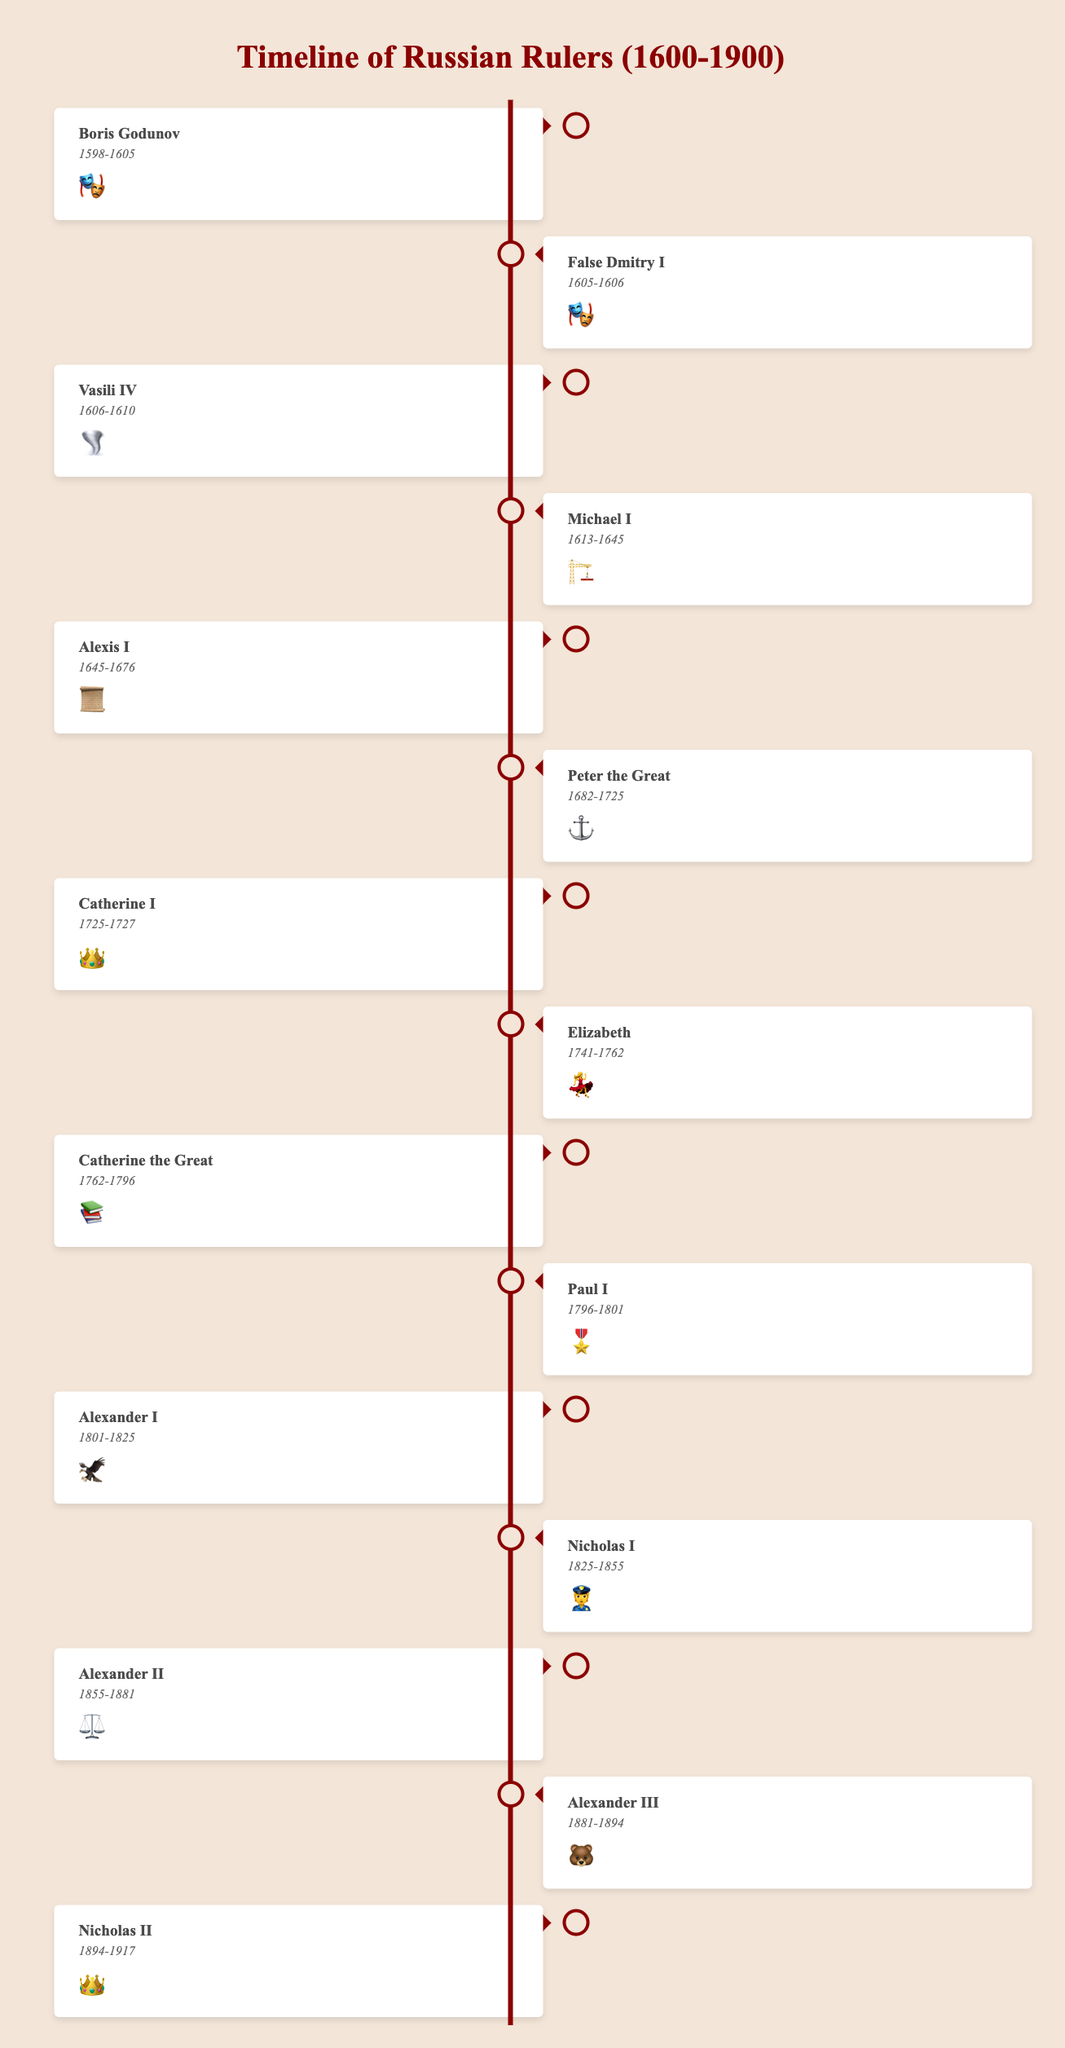How long did Boris Godunov rule? The timeline indicates that Boris Godunov ruled from 1598 to 1605. The length of his reign is the difference between these two years. 1605 - 1598 = 7 years.
Answer: 7 years Which ruler has the emoji 🎭 and what does it signify about them? Both Boris Godunov and False Dmitry I have the emoji 🎭. This likely signifies a dramatic or theatrical aspect of their reigns.
Answer: Boris Godunov and False Dmitry I Who was the ruler during the reign period 1762-1796 and what was their notable characteristic? From the timeline, it shows that Catherine the Great ruled from 1762 to 1796. Her notable characteristic is represented by the emoji 📚, indicating education or enlightenment.
Answer: Catherine the Great, 📚 Which ruler reigned directly after Peter the Great and what emoji represents them? According to the timeline, Catherine I ruled directly after Peter the Great. She is represented by the emoji 👑.
Answer: Catherine I, 👑 Compare the reign periods of Alexis I and Michael I. Who ruled longer and by how many years? Michael I reigned from 1613-1645 (32 years) and Alexis I from 1645-1676 (31 years). Michael I ruled longer by 1 year.
Answer: Michael I, 1 year longer Identify the ruler whose reign is represented by the emoji ⚓ and explain what it might symbolize. Peter the Great's reign, depicted by the emoji ⚓, possibly symbolizes his naval reforms and the expansion of the Russian navy.
Answer: Peter the Great, ⚓ What is the combined length of reigns for the rulers depicted with an emoji of a book? The only ruler with the book emoji (📚) is Catherine the Great, who ruled from 1762 to 1796, which totals 34 years.
Answer: 34 years How many rulers reigned from 1800-1900, and what are their notable characteristics? From the timeline, Alexander I (🦅), Nicholas I (👮), Alexander II (⚖️), Alexander III (🐻), and Nicholas II (👑) reigned during this period. This totals five rulers who had symbols of an eagle, a policeman, scales of justice, a bear, and a crown respectively.
Answer: 5 rulers, 🦅👮⚖️🐻👑 Which reign directly succeeded the "Time of Troubles" and how long did it last? The ruler Michael I started reigning in 1613, directly after the "Time of Troubles" which ended in 1613. His reign lasted until 1645.
Answer: Michael I, 32 years During whose rule did the Decembrist revolt take place and what was their emoji? The Decembrist revolt occurred in 1825 during the reign of Nicholas I, represented by the emoji 👮.
Answer: Nicholas I, 👮 